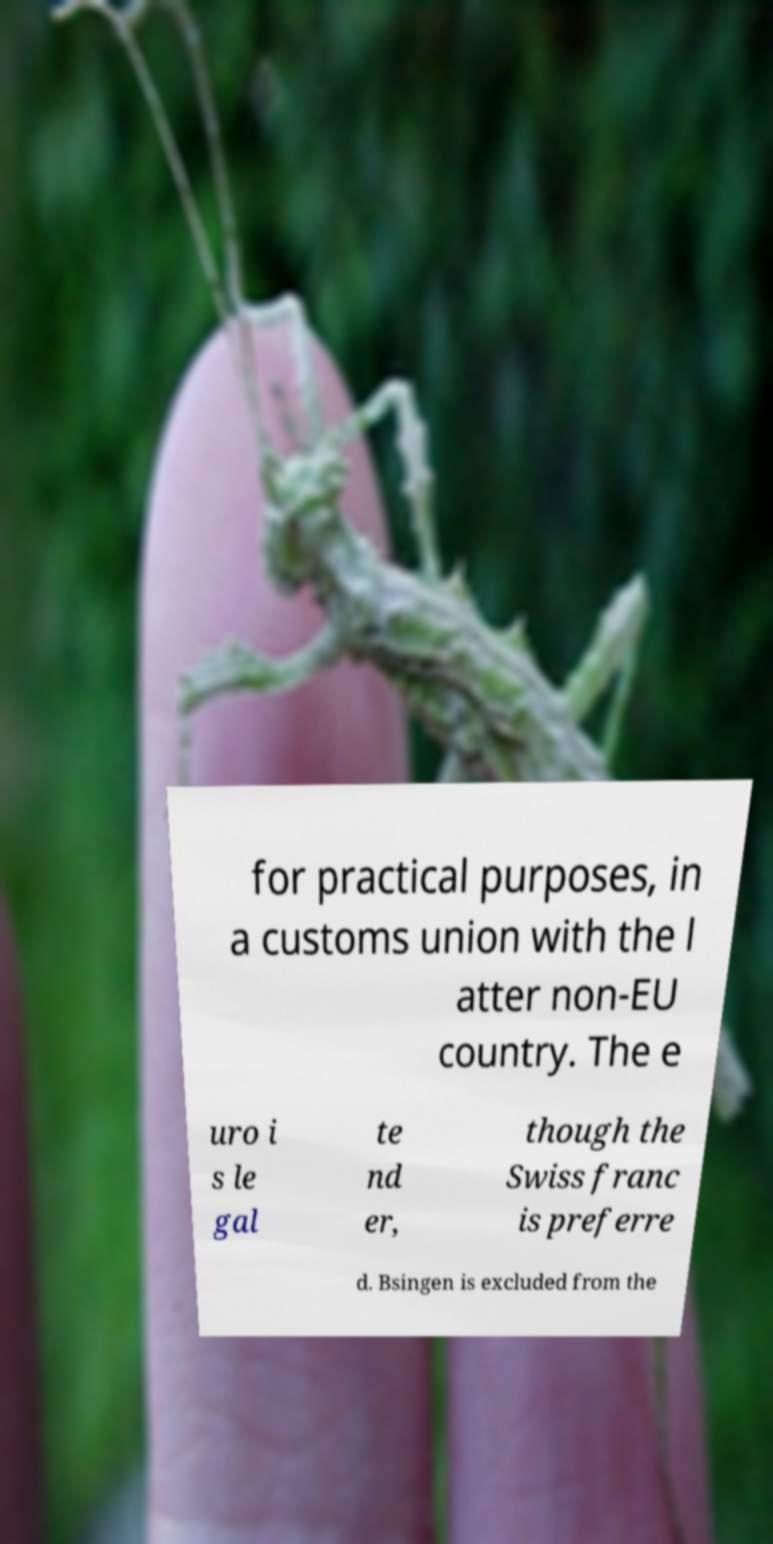There's text embedded in this image that I need extracted. Can you transcribe it verbatim? for practical purposes, in a customs union with the l atter non-EU country. The e uro i s le gal te nd er, though the Swiss franc is preferre d. Bsingen is excluded from the 